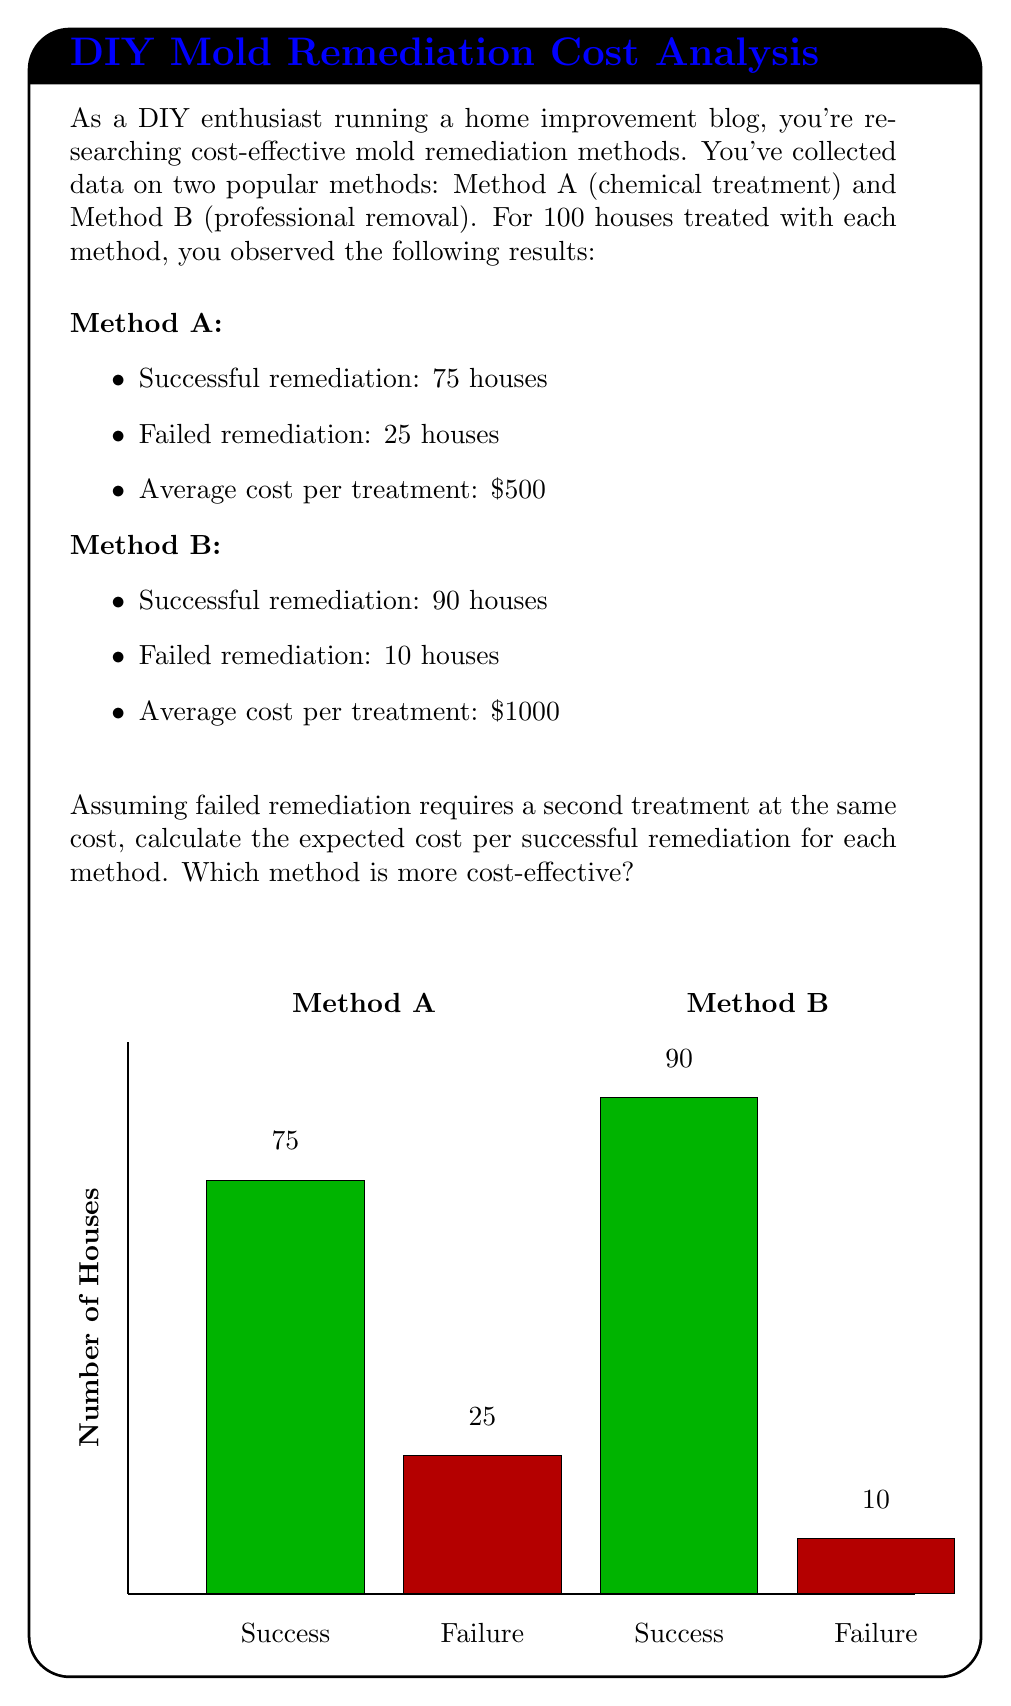Solve this math problem. Let's approach this problem step-by-step:

1) First, we need to calculate the probability of success for each method:

   Method A: $P(A_{success}) = \frac{75}{100} = 0.75$
   Method B: $P(B_{success}) = \frac{90}{100} = 0.90$

2) Now, let's calculate the expected number of treatments needed for each method:

   Method A: $E(A_{treatments}) = 1 \cdot P(A_{success}) + 2 \cdot P(A_{failure}) = 1 \cdot 0.75 + 2 \cdot 0.25 = 1.25$
   Method B: $E(B_{treatments}) = 1 \cdot P(B_{success}) + 2 \cdot P(B_{failure}) = 1 \cdot 0.90 + 2 \cdot 0.10 = 1.10$

3) Next, we calculate the expected cost for each method:

   Method A: $E(A_{cost}) = 500 \cdot E(A_{treatments}) = 500 \cdot 1.25 = \$625$
   Method B: $E(B_{cost}) = 1000 \cdot E(B_{treatments}) = 1000 \cdot 1.10 = \$1100$

4) Finally, we calculate the expected cost per successful remediation:

   Method A: $E(A_{cost/success}) = \frac{E(A_{cost})}{P(A_{success})} = \frac{625}{0.75} = \$833.33$
   Method B: $E(B_{cost/success}) = \frac{E(B_{cost})}{P(B_{success})} = \frac{1100}{0.90} = \$1222.22$

5) Comparing the two methods:

   Method A costs $833.33 per successful remediation.
   Method B costs $1222.22 per successful remediation.

Therefore, Method A is more cost-effective, despite having a lower success rate, due to its significantly lower initial cost.
Answer: Method A: $\$833.33 per successful remediation; Method B: $\$1222.22 per successful remediation. Method A is more cost-effective. 